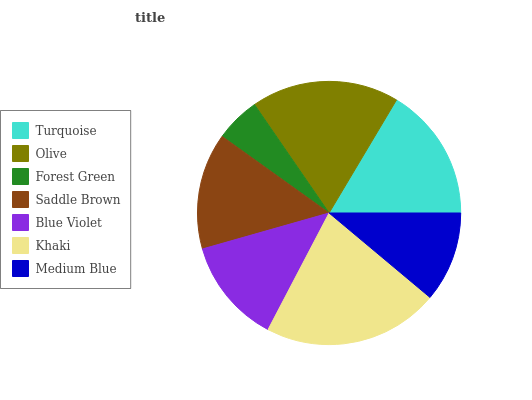Is Forest Green the minimum?
Answer yes or no. Yes. Is Khaki the maximum?
Answer yes or no. Yes. Is Olive the minimum?
Answer yes or no. No. Is Olive the maximum?
Answer yes or no. No. Is Olive greater than Turquoise?
Answer yes or no. Yes. Is Turquoise less than Olive?
Answer yes or no. Yes. Is Turquoise greater than Olive?
Answer yes or no. No. Is Olive less than Turquoise?
Answer yes or no. No. Is Saddle Brown the high median?
Answer yes or no. Yes. Is Saddle Brown the low median?
Answer yes or no. Yes. Is Turquoise the high median?
Answer yes or no. No. Is Olive the low median?
Answer yes or no. No. 